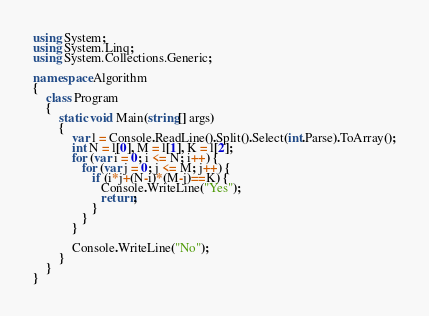<code> <loc_0><loc_0><loc_500><loc_500><_C#_>using System;
using System.Linq;
using System.Collections.Generic;

namespace Algorithm
{
    class Program
    {
        static void Main(string[] args)
        {
            var l = Console.ReadLine().Split().Select(int.Parse).ToArray();
            int N = l[0], M = l[1], K = l[2];
            for (var i = 0; i <= N; i++) {
               for (var j = 0; j <= M; j++) {
                  if (i*j+(N-i)*(M-j)==K) {
                     Console.WriteLine("Yes");
                     return; 
                  } 
               } 
            }
                
            Console.WriteLine("No");
        }
    }
}
</code> 